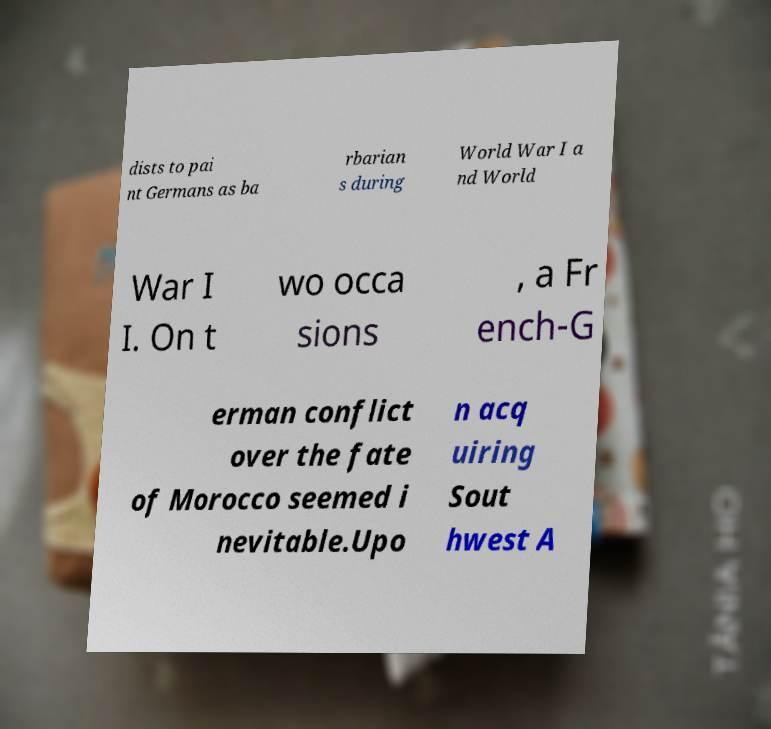Could you assist in decoding the text presented in this image and type it out clearly? dists to pai nt Germans as ba rbarian s during World War I a nd World War I I. On t wo occa sions , a Fr ench-G erman conflict over the fate of Morocco seemed i nevitable.Upo n acq uiring Sout hwest A 